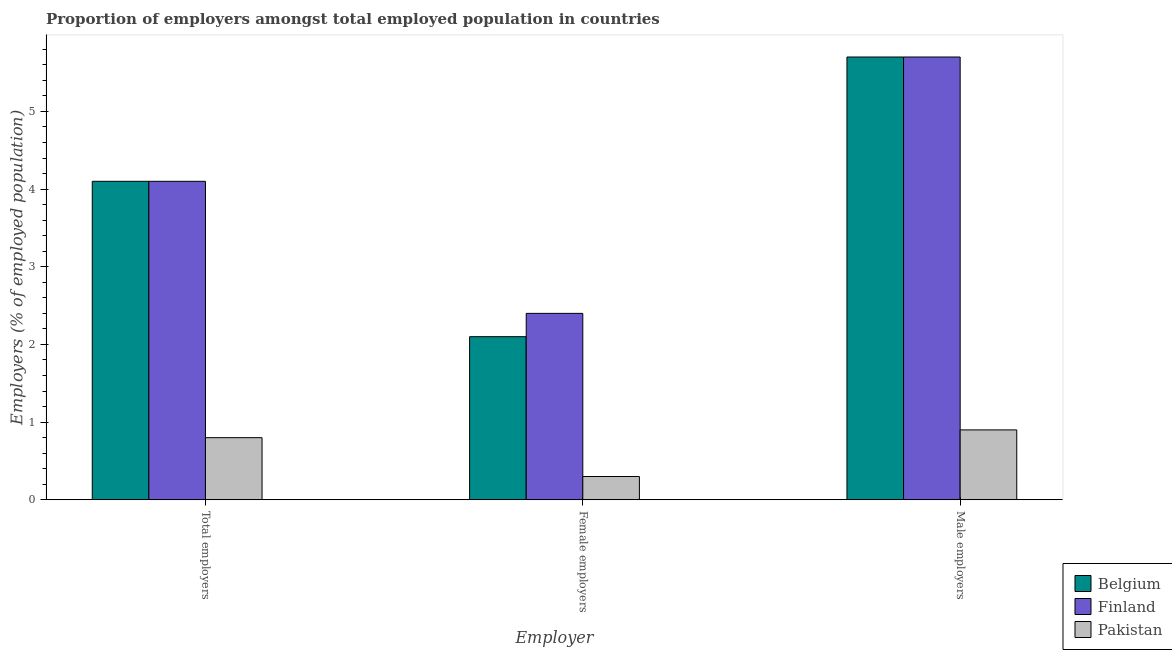Are the number of bars on each tick of the X-axis equal?
Keep it short and to the point. Yes. How many bars are there on the 1st tick from the left?
Your answer should be very brief. 3. How many bars are there on the 1st tick from the right?
Your answer should be very brief. 3. What is the label of the 3rd group of bars from the left?
Your answer should be very brief. Male employers. What is the percentage of total employers in Belgium?
Offer a terse response. 4.1. Across all countries, what is the maximum percentage of female employers?
Ensure brevity in your answer.  2.4. Across all countries, what is the minimum percentage of female employers?
Keep it short and to the point. 0.3. In which country was the percentage of female employers maximum?
Give a very brief answer. Finland. In which country was the percentage of male employers minimum?
Keep it short and to the point. Pakistan. What is the total percentage of male employers in the graph?
Provide a succinct answer. 12.3. What is the difference between the percentage of male employers in Pakistan and that in Belgium?
Offer a terse response. -4.8. What is the difference between the percentage of male employers in Finland and the percentage of female employers in Belgium?
Make the answer very short. 3.6. What is the average percentage of total employers per country?
Provide a succinct answer. 3. What is the difference between the percentage of female employers and percentage of total employers in Pakistan?
Give a very brief answer. -0.5. What is the ratio of the percentage of male employers in Pakistan to that in Finland?
Your answer should be very brief. 0.16. Is the percentage of male employers in Pakistan less than that in Belgium?
Your answer should be compact. Yes. Is the difference between the percentage of female employers in Finland and Pakistan greater than the difference between the percentage of total employers in Finland and Pakistan?
Offer a very short reply. No. What is the difference between the highest and the second highest percentage of female employers?
Give a very brief answer. 0.3. What is the difference between the highest and the lowest percentage of female employers?
Offer a terse response. 2.1. In how many countries, is the percentage of male employers greater than the average percentage of male employers taken over all countries?
Provide a short and direct response. 2. Is the sum of the percentage of total employers in Pakistan and Finland greater than the maximum percentage of male employers across all countries?
Provide a succinct answer. No. What does the 2nd bar from the left in Female employers represents?
Your answer should be compact. Finland. Does the graph contain any zero values?
Your answer should be compact. No. Where does the legend appear in the graph?
Offer a very short reply. Bottom right. What is the title of the graph?
Offer a terse response. Proportion of employers amongst total employed population in countries. What is the label or title of the X-axis?
Offer a terse response. Employer. What is the label or title of the Y-axis?
Offer a terse response. Employers (% of employed population). What is the Employers (% of employed population) in Belgium in Total employers?
Your response must be concise. 4.1. What is the Employers (% of employed population) in Finland in Total employers?
Your answer should be compact. 4.1. What is the Employers (% of employed population) of Pakistan in Total employers?
Provide a short and direct response. 0.8. What is the Employers (% of employed population) in Belgium in Female employers?
Your answer should be compact. 2.1. What is the Employers (% of employed population) in Finland in Female employers?
Provide a short and direct response. 2.4. What is the Employers (% of employed population) in Pakistan in Female employers?
Provide a short and direct response. 0.3. What is the Employers (% of employed population) in Belgium in Male employers?
Make the answer very short. 5.7. What is the Employers (% of employed population) of Finland in Male employers?
Ensure brevity in your answer.  5.7. What is the Employers (% of employed population) of Pakistan in Male employers?
Offer a very short reply. 0.9. Across all Employer, what is the maximum Employers (% of employed population) of Belgium?
Make the answer very short. 5.7. Across all Employer, what is the maximum Employers (% of employed population) of Finland?
Your answer should be compact. 5.7. Across all Employer, what is the maximum Employers (% of employed population) of Pakistan?
Your response must be concise. 0.9. Across all Employer, what is the minimum Employers (% of employed population) in Belgium?
Your answer should be very brief. 2.1. Across all Employer, what is the minimum Employers (% of employed population) of Finland?
Ensure brevity in your answer.  2.4. Across all Employer, what is the minimum Employers (% of employed population) in Pakistan?
Your answer should be compact. 0.3. What is the total Employers (% of employed population) in Pakistan in the graph?
Make the answer very short. 2. What is the difference between the Employers (% of employed population) in Pakistan in Total employers and that in Female employers?
Provide a short and direct response. 0.5. What is the difference between the Employers (% of employed population) in Finland in Total employers and that in Male employers?
Offer a very short reply. -1.6. What is the difference between the Employers (% of employed population) in Finland in Total employers and the Employers (% of employed population) in Pakistan in Female employers?
Your response must be concise. 3.8. What is the difference between the Employers (% of employed population) in Belgium in Total employers and the Employers (% of employed population) in Finland in Male employers?
Offer a very short reply. -1.6. What is the difference between the Employers (% of employed population) of Finland in Total employers and the Employers (% of employed population) of Pakistan in Male employers?
Provide a succinct answer. 3.2. What is the difference between the Employers (% of employed population) in Belgium in Female employers and the Employers (% of employed population) in Pakistan in Male employers?
Keep it short and to the point. 1.2. What is the difference between the Employers (% of employed population) in Finland in Female employers and the Employers (% of employed population) in Pakistan in Male employers?
Give a very brief answer. 1.5. What is the average Employers (% of employed population) in Belgium per Employer?
Provide a short and direct response. 3.97. What is the average Employers (% of employed population) of Finland per Employer?
Your answer should be compact. 4.07. What is the average Employers (% of employed population) of Pakistan per Employer?
Your answer should be very brief. 0.67. What is the difference between the Employers (% of employed population) in Belgium and Employers (% of employed population) in Pakistan in Female employers?
Provide a succinct answer. 1.8. What is the difference between the Employers (% of employed population) of Finland and Employers (% of employed population) of Pakistan in Female employers?
Make the answer very short. 2.1. What is the ratio of the Employers (% of employed population) of Belgium in Total employers to that in Female employers?
Ensure brevity in your answer.  1.95. What is the ratio of the Employers (% of employed population) in Finland in Total employers to that in Female employers?
Your answer should be very brief. 1.71. What is the ratio of the Employers (% of employed population) of Pakistan in Total employers to that in Female employers?
Your response must be concise. 2.67. What is the ratio of the Employers (% of employed population) of Belgium in Total employers to that in Male employers?
Make the answer very short. 0.72. What is the ratio of the Employers (% of employed population) in Finland in Total employers to that in Male employers?
Offer a very short reply. 0.72. What is the ratio of the Employers (% of employed population) of Pakistan in Total employers to that in Male employers?
Provide a succinct answer. 0.89. What is the ratio of the Employers (% of employed population) in Belgium in Female employers to that in Male employers?
Keep it short and to the point. 0.37. What is the ratio of the Employers (% of employed population) of Finland in Female employers to that in Male employers?
Your answer should be compact. 0.42. What is the ratio of the Employers (% of employed population) in Pakistan in Female employers to that in Male employers?
Your answer should be very brief. 0.33. What is the difference between the highest and the second highest Employers (% of employed population) of Belgium?
Offer a very short reply. 1.6. What is the difference between the highest and the second highest Employers (% of employed population) in Finland?
Ensure brevity in your answer.  1.6. What is the difference between the highest and the second highest Employers (% of employed population) of Pakistan?
Your response must be concise. 0.1. What is the difference between the highest and the lowest Employers (% of employed population) in Belgium?
Make the answer very short. 3.6. What is the difference between the highest and the lowest Employers (% of employed population) in Pakistan?
Ensure brevity in your answer.  0.6. 